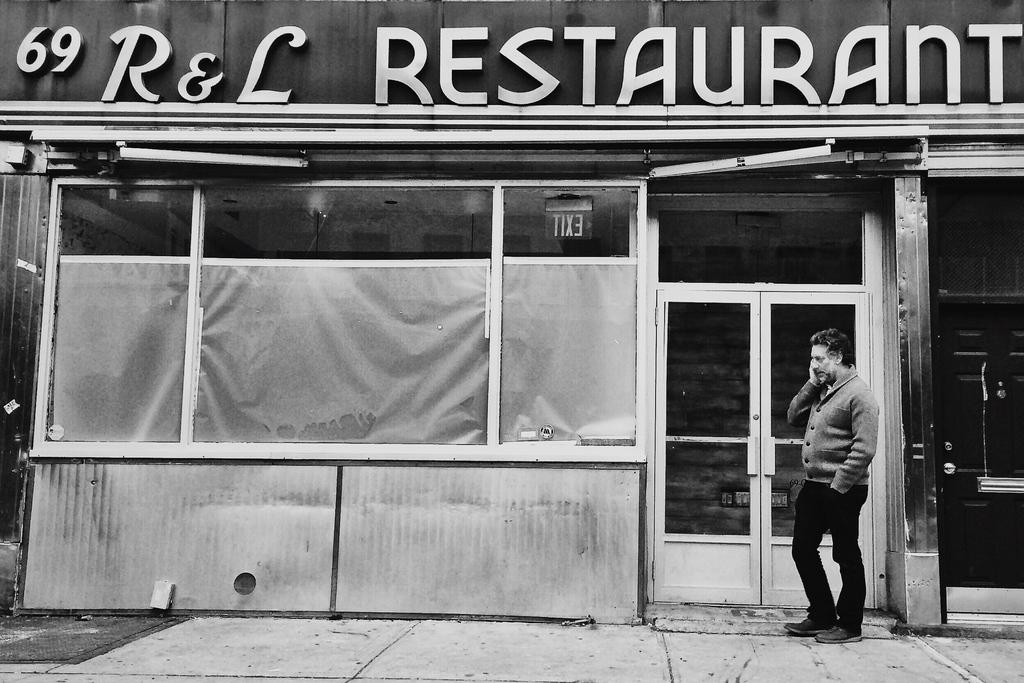What is the main subject of the image? There is a man standing in the image. What can be seen in the background of the image? There is a shop in the background of the image. What features does the shop have? The shop has a door and a name on it. How is the image presented in terms of color? The image is black and white in color. What type of scarf is the man wearing in the image? The image is black and white, and there is no indication of a scarf being worn by the man. Can you tell me how many earths are visible in the image? There are no earths present in the image; it features a man standing in front of a shop. 